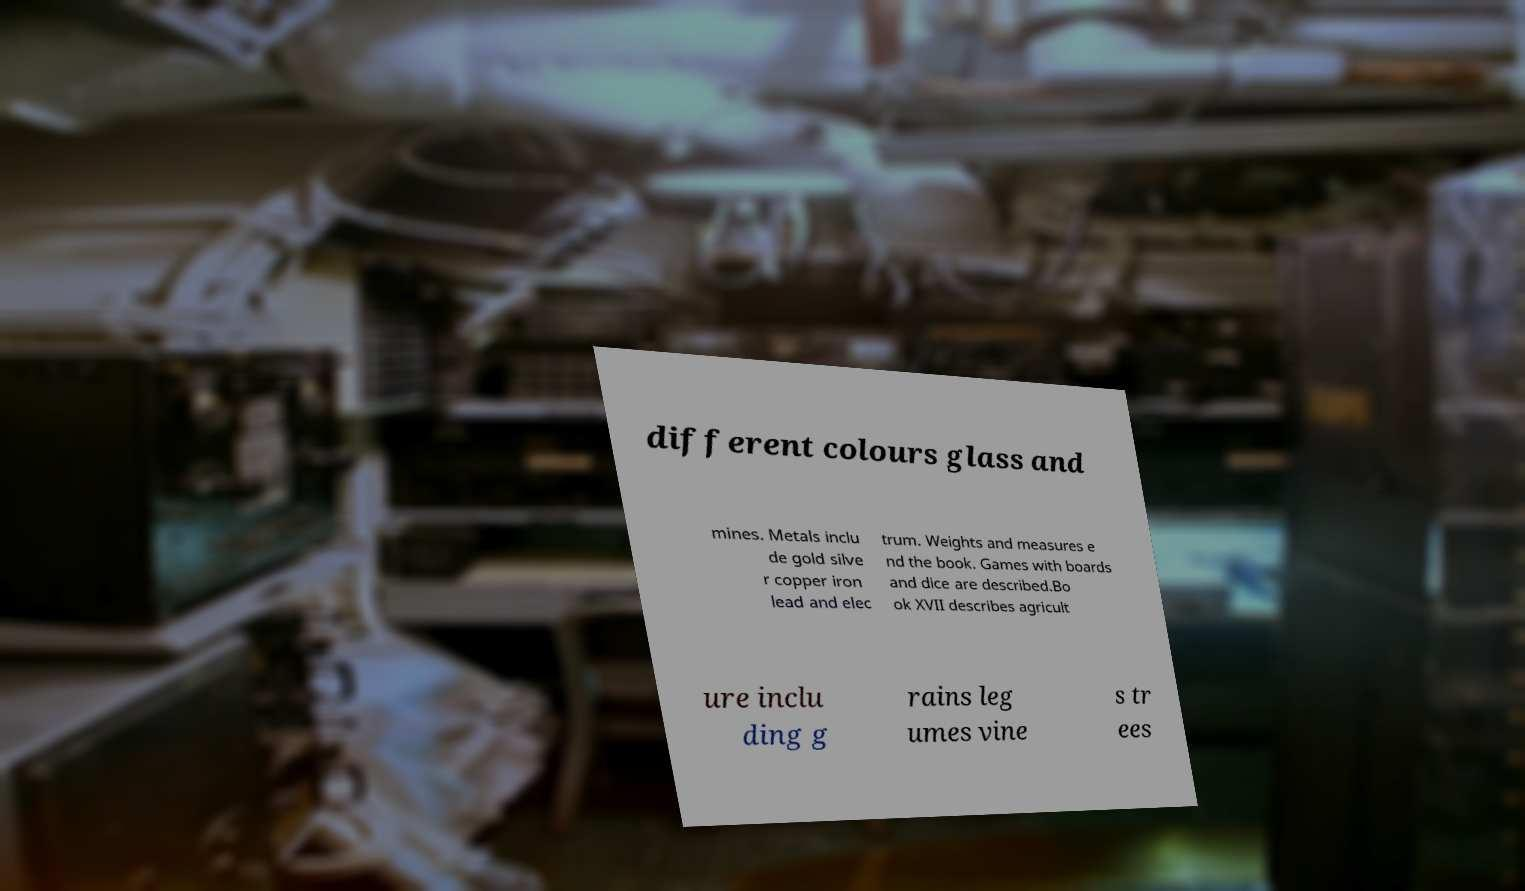There's text embedded in this image that I need extracted. Can you transcribe it verbatim? different colours glass and mines. Metals inclu de gold silve r copper iron lead and elec trum. Weights and measures e nd the book. Games with boards and dice are described.Bo ok XVII describes agricult ure inclu ding g rains leg umes vine s tr ees 